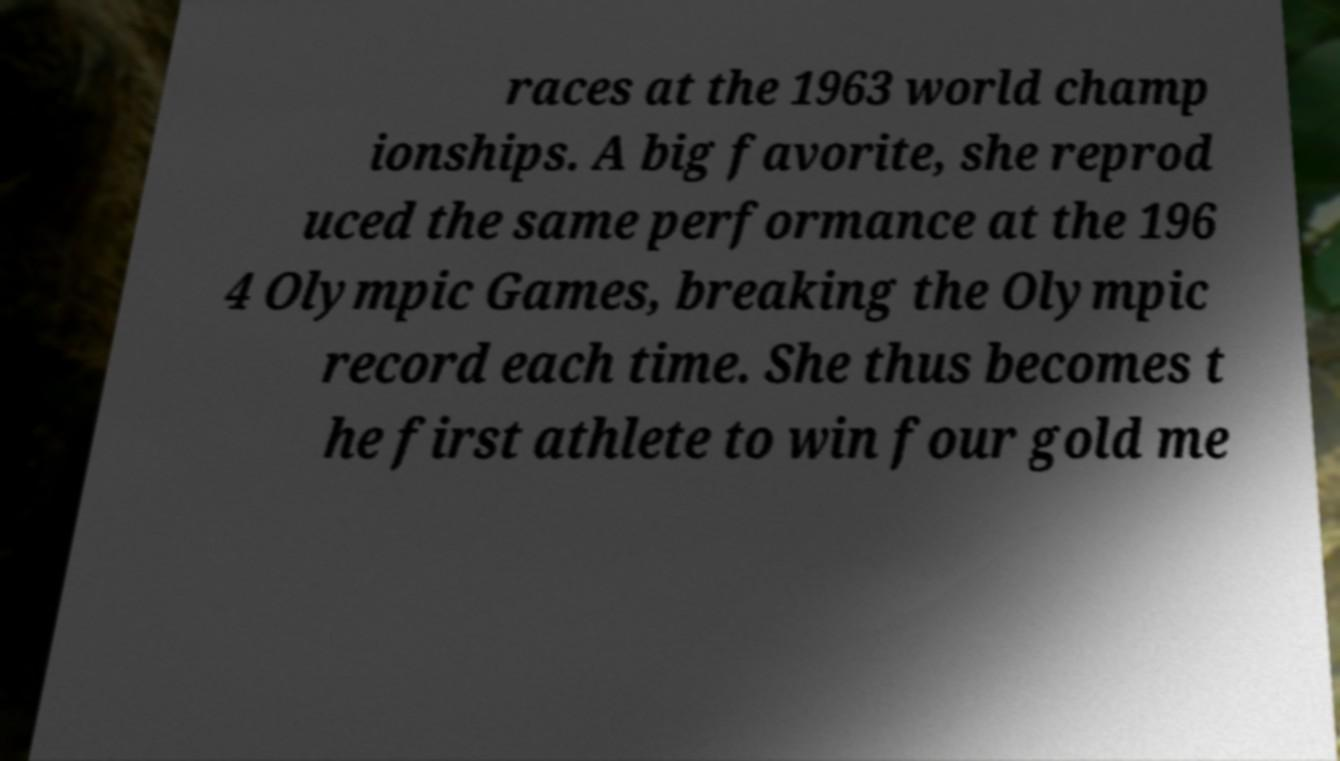What messages or text are displayed in this image? I need them in a readable, typed format. races at the 1963 world champ ionships. A big favorite, she reprod uced the same performance at the 196 4 Olympic Games, breaking the Olympic record each time. She thus becomes t he first athlete to win four gold me 